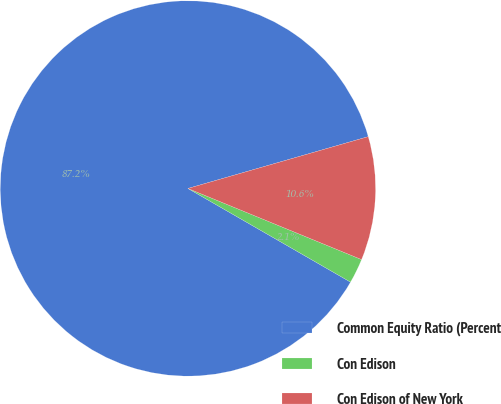Convert chart to OTSL. <chart><loc_0><loc_0><loc_500><loc_500><pie_chart><fcel>Common Equity Ratio (Percent<fcel>Con Edison<fcel>Con Edison of New York<nl><fcel>87.23%<fcel>2.13%<fcel>10.64%<nl></chart> 